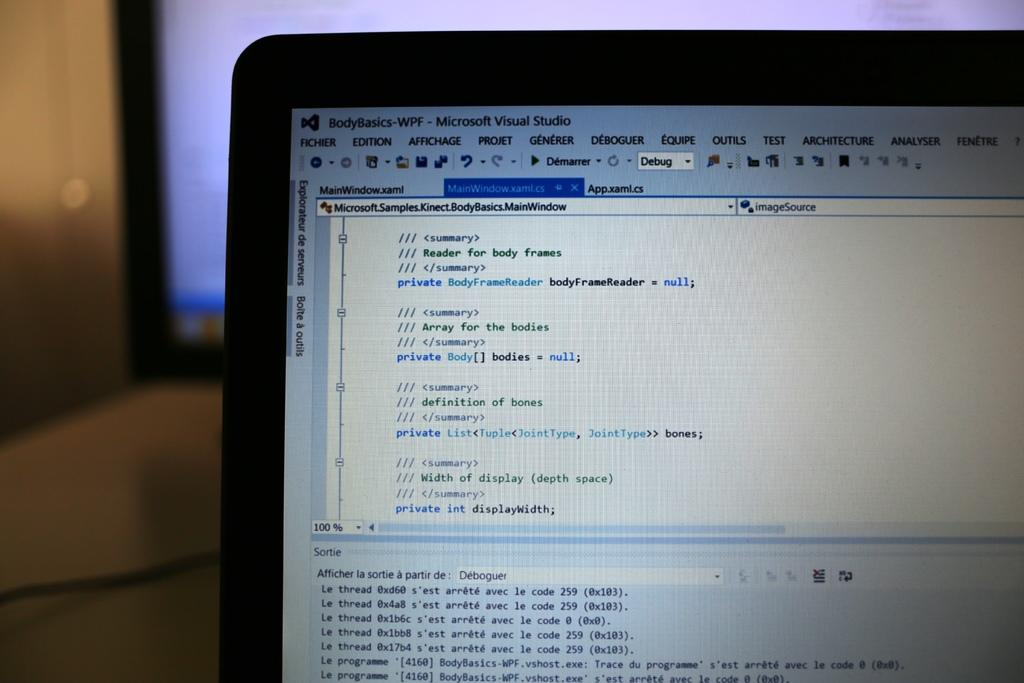<image>
Summarize the visual content of the image. A laptop screen has a program open called Microsoft Visual Studio. 